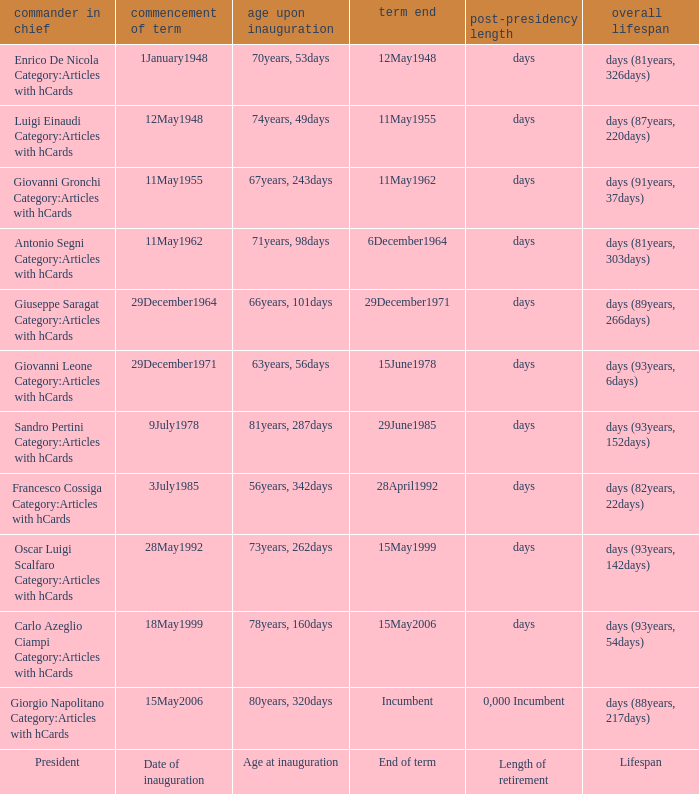What is the Date of inauguration of the President with an Age at inauguration of 73years, 262days? 28May1992. 